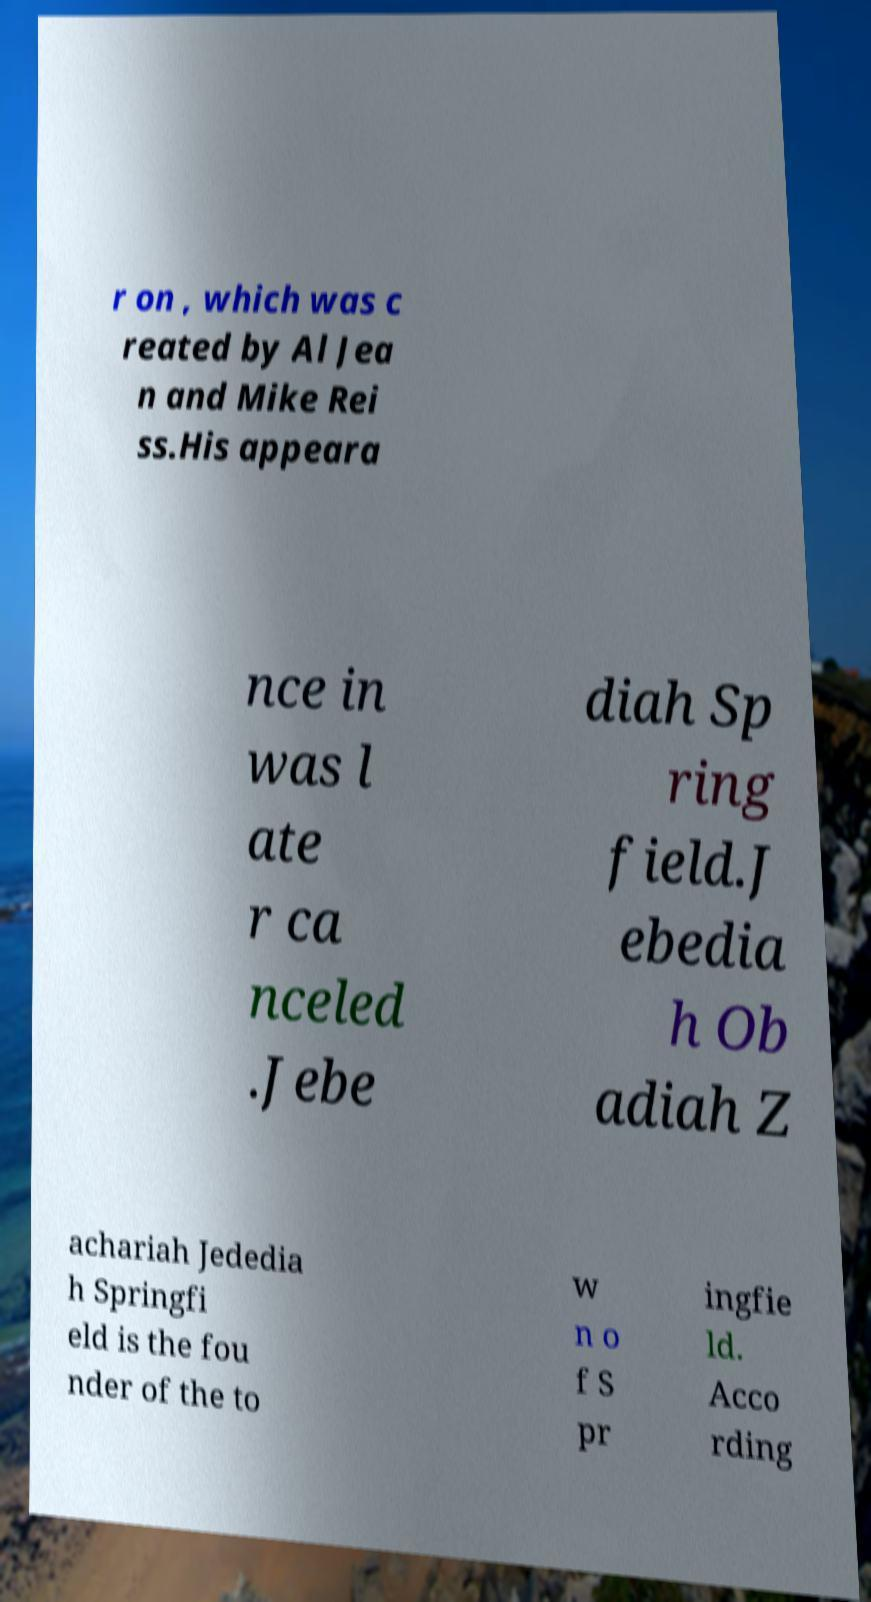What messages or text are displayed in this image? I need them in a readable, typed format. r on , which was c reated by Al Jea n and Mike Rei ss.His appeara nce in was l ate r ca nceled .Jebe diah Sp ring field.J ebedia h Ob adiah Z achariah Jededia h Springfi eld is the fou nder of the to w n o f S pr ingfie ld. Acco rding 